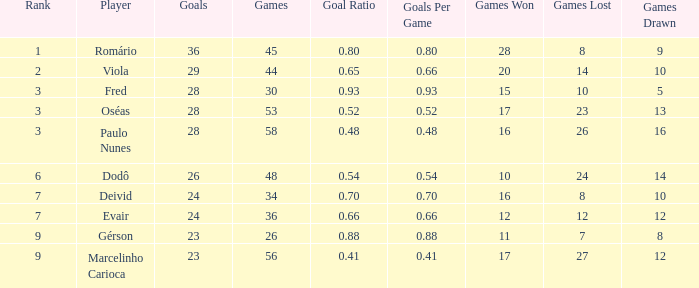How many games have 23 goals with a rank greater than 9? 0.0. 